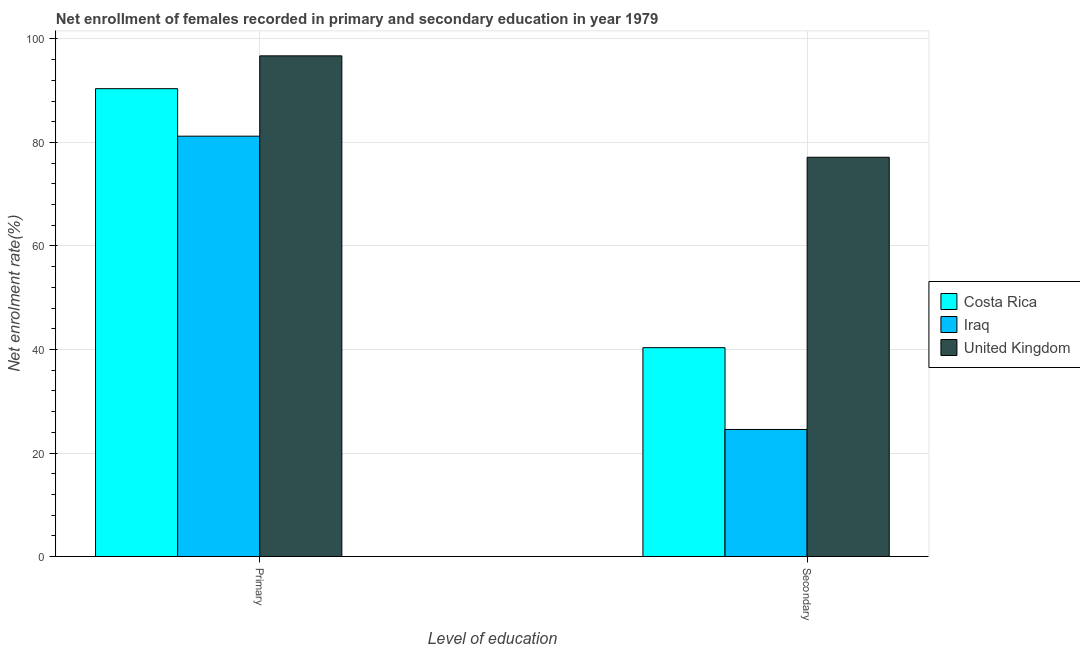How many different coloured bars are there?
Give a very brief answer. 3. How many groups of bars are there?
Your answer should be very brief. 2. Are the number of bars per tick equal to the number of legend labels?
Offer a very short reply. Yes. How many bars are there on the 1st tick from the left?
Give a very brief answer. 3. How many bars are there on the 1st tick from the right?
Make the answer very short. 3. What is the label of the 2nd group of bars from the left?
Your answer should be compact. Secondary. What is the enrollment rate in secondary education in Iraq?
Make the answer very short. 24.55. Across all countries, what is the maximum enrollment rate in primary education?
Offer a terse response. 96.74. Across all countries, what is the minimum enrollment rate in secondary education?
Make the answer very short. 24.55. In which country was the enrollment rate in secondary education minimum?
Your answer should be very brief. Iraq. What is the total enrollment rate in secondary education in the graph?
Provide a succinct answer. 142.05. What is the difference between the enrollment rate in primary education in Iraq and that in Costa Rica?
Ensure brevity in your answer.  -9.18. What is the difference between the enrollment rate in primary education in Costa Rica and the enrollment rate in secondary education in United Kingdom?
Give a very brief answer. 13.25. What is the average enrollment rate in secondary education per country?
Offer a very short reply. 47.35. What is the difference between the enrollment rate in secondary education and enrollment rate in primary education in United Kingdom?
Your answer should be very brief. -19.59. In how many countries, is the enrollment rate in secondary education greater than 12 %?
Your answer should be compact. 3. What is the ratio of the enrollment rate in secondary education in Iraq to that in Costa Rica?
Give a very brief answer. 0.61. In how many countries, is the enrollment rate in secondary education greater than the average enrollment rate in secondary education taken over all countries?
Make the answer very short. 1. What does the 1st bar from the right in Secondary represents?
Offer a terse response. United Kingdom. How many bars are there?
Your response must be concise. 6. Are all the bars in the graph horizontal?
Offer a terse response. No. Does the graph contain any zero values?
Give a very brief answer. No. What is the title of the graph?
Make the answer very short. Net enrollment of females recorded in primary and secondary education in year 1979. What is the label or title of the X-axis?
Give a very brief answer. Level of education. What is the label or title of the Y-axis?
Provide a short and direct response. Net enrolment rate(%). What is the Net enrolment rate(%) in Costa Rica in Primary?
Offer a very short reply. 90.39. What is the Net enrolment rate(%) of Iraq in Primary?
Provide a succinct answer. 81.22. What is the Net enrolment rate(%) in United Kingdom in Primary?
Ensure brevity in your answer.  96.74. What is the Net enrolment rate(%) in Costa Rica in Secondary?
Give a very brief answer. 40.36. What is the Net enrolment rate(%) of Iraq in Secondary?
Give a very brief answer. 24.55. What is the Net enrolment rate(%) in United Kingdom in Secondary?
Give a very brief answer. 77.15. Across all Level of education, what is the maximum Net enrolment rate(%) in Costa Rica?
Provide a succinct answer. 90.39. Across all Level of education, what is the maximum Net enrolment rate(%) of Iraq?
Your response must be concise. 81.22. Across all Level of education, what is the maximum Net enrolment rate(%) in United Kingdom?
Ensure brevity in your answer.  96.74. Across all Level of education, what is the minimum Net enrolment rate(%) of Costa Rica?
Give a very brief answer. 40.36. Across all Level of education, what is the minimum Net enrolment rate(%) in Iraq?
Offer a very short reply. 24.55. Across all Level of education, what is the minimum Net enrolment rate(%) of United Kingdom?
Provide a short and direct response. 77.15. What is the total Net enrolment rate(%) of Costa Rica in the graph?
Your response must be concise. 130.75. What is the total Net enrolment rate(%) of Iraq in the graph?
Make the answer very short. 105.76. What is the total Net enrolment rate(%) of United Kingdom in the graph?
Your answer should be compact. 173.88. What is the difference between the Net enrolment rate(%) of Costa Rica in Primary and that in Secondary?
Your answer should be very brief. 50.04. What is the difference between the Net enrolment rate(%) of Iraq in Primary and that in Secondary?
Offer a very short reply. 56.67. What is the difference between the Net enrolment rate(%) in United Kingdom in Primary and that in Secondary?
Provide a short and direct response. 19.59. What is the difference between the Net enrolment rate(%) in Costa Rica in Primary and the Net enrolment rate(%) in Iraq in Secondary?
Your answer should be very brief. 65.85. What is the difference between the Net enrolment rate(%) of Costa Rica in Primary and the Net enrolment rate(%) of United Kingdom in Secondary?
Offer a terse response. 13.25. What is the difference between the Net enrolment rate(%) in Iraq in Primary and the Net enrolment rate(%) in United Kingdom in Secondary?
Your answer should be compact. 4.07. What is the average Net enrolment rate(%) of Costa Rica per Level of education?
Keep it short and to the point. 65.38. What is the average Net enrolment rate(%) in Iraq per Level of education?
Give a very brief answer. 52.88. What is the average Net enrolment rate(%) in United Kingdom per Level of education?
Ensure brevity in your answer.  86.94. What is the difference between the Net enrolment rate(%) in Costa Rica and Net enrolment rate(%) in Iraq in Primary?
Give a very brief answer. 9.18. What is the difference between the Net enrolment rate(%) in Costa Rica and Net enrolment rate(%) in United Kingdom in Primary?
Your answer should be very brief. -6.34. What is the difference between the Net enrolment rate(%) in Iraq and Net enrolment rate(%) in United Kingdom in Primary?
Your answer should be compact. -15.52. What is the difference between the Net enrolment rate(%) in Costa Rica and Net enrolment rate(%) in Iraq in Secondary?
Give a very brief answer. 15.81. What is the difference between the Net enrolment rate(%) of Costa Rica and Net enrolment rate(%) of United Kingdom in Secondary?
Give a very brief answer. -36.79. What is the difference between the Net enrolment rate(%) in Iraq and Net enrolment rate(%) in United Kingdom in Secondary?
Keep it short and to the point. -52.6. What is the ratio of the Net enrolment rate(%) of Costa Rica in Primary to that in Secondary?
Offer a terse response. 2.24. What is the ratio of the Net enrolment rate(%) in Iraq in Primary to that in Secondary?
Provide a succinct answer. 3.31. What is the ratio of the Net enrolment rate(%) of United Kingdom in Primary to that in Secondary?
Your answer should be compact. 1.25. What is the difference between the highest and the second highest Net enrolment rate(%) in Costa Rica?
Your response must be concise. 50.04. What is the difference between the highest and the second highest Net enrolment rate(%) of Iraq?
Your response must be concise. 56.67. What is the difference between the highest and the second highest Net enrolment rate(%) in United Kingdom?
Provide a succinct answer. 19.59. What is the difference between the highest and the lowest Net enrolment rate(%) in Costa Rica?
Ensure brevity in your answer.  50.04. What is the difference between the highest and the lowest Net enrolment rate(%) of Iraq?
Make the answer very short. 56.67. What is the difference between the highest and the lowest Net enrolment rate(%) in United Kingdom?
Keep it short and to the point. 19.59. 